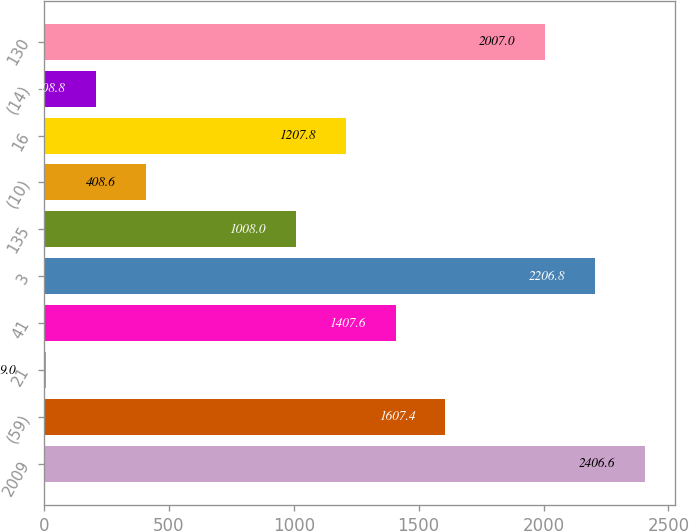Convert chart. <chart><loc_0><loc_0><loc_500><loc_500><bar_chart><fcel>2009<fcel>(59)<fcel>21<fcel>41<fcel>3<fcel>135<fcel>(10)<fcel>16<fcel>(14)<fcel>130<nl><fcel>2406.6<fcel>1607.4<fcel>9<fcel>1407.6<fcel>2206.8<fcel>1008<fcel>408.6<fcel>1207.8<fcel>208.8<fcel>2007<nl></chart> 